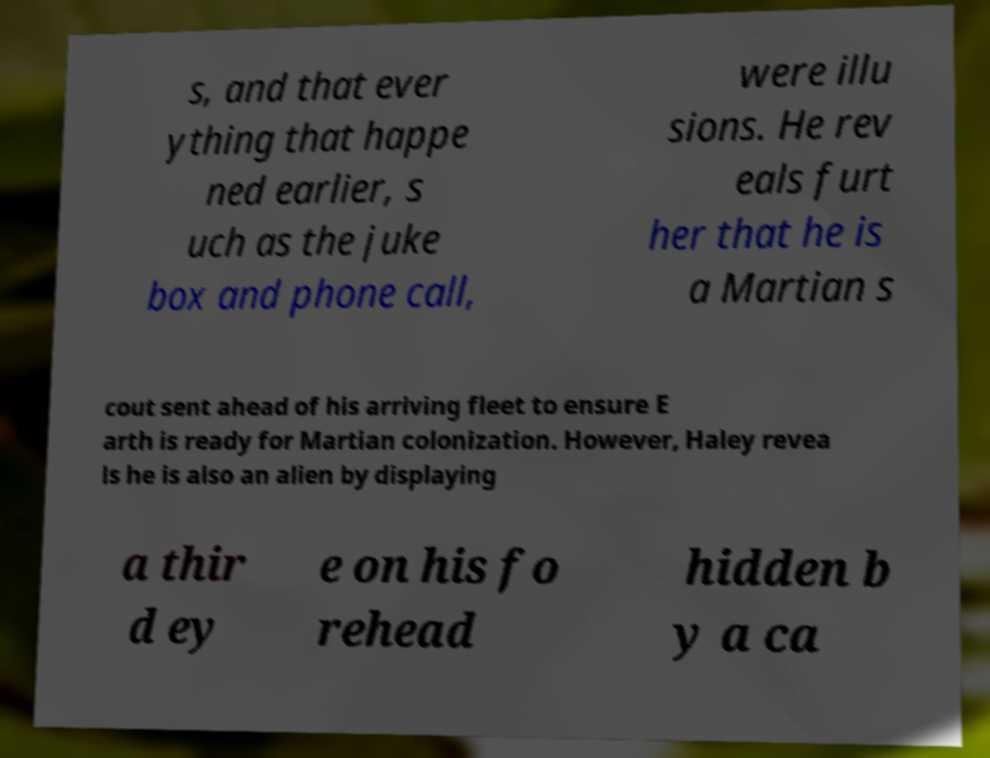Can you read and provide the text displayed in the image?This photo seems to have some interesting text. Can you extract and type it out for me? s, and that ever ything that happe ned earlier, s uch as the juke box and phone call, were illu sions. He rev eals furt her that he is a Martian s cout sent ahead of his arriving fleet to ensure E arth is ready for Martian colonization. However, Haley revea ls he is also an alien by displaying a thir d ey e on his fo rehead hidden b y a ca 